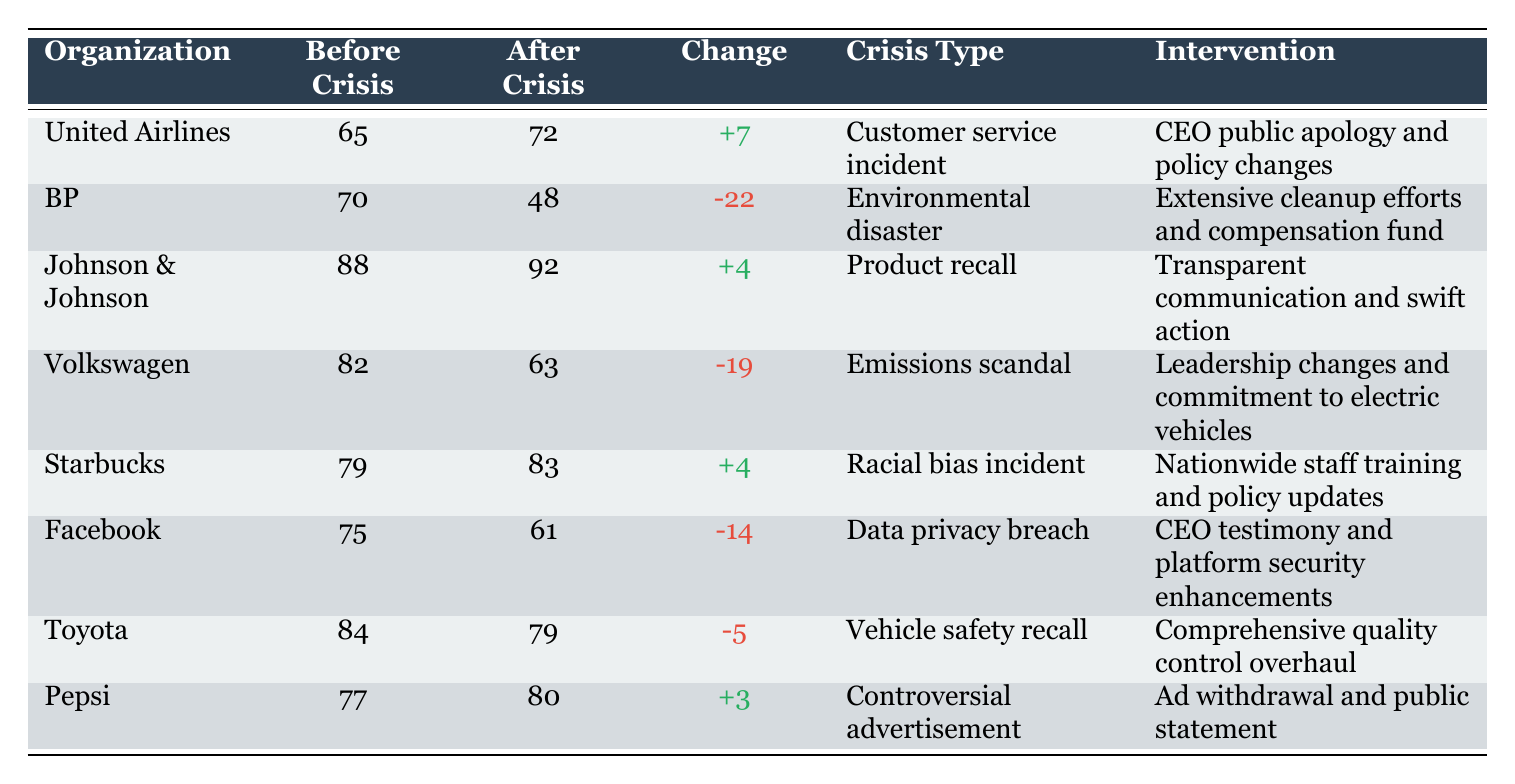What was the public perception rating of United Airlines before the crisis? The table indicates that United Airlines had a public perception rating of 65 before the crisis occurred.
Answer: 65 What intervention did Johnson & Johnson implement after their crisis? According to the table, Johnson & Johnson implemented "Transparent communication and swift action" after their crisis intervention.
Answer: Transparent communication and swift action Which organization experienced the largest decrease in public perception ratings after a crisis? By examining the table, BP's rating decreased from 70 to 48, which is a change of -22, the largest among all organizations.
Answer: BP What is the average public perception rating before the crises for the organizations listed? To calculate the average, sum the ratings before the crises: (65 + 70 + 88 + 82 + 79 + 75 + 84 + 77) = 720. There are 8 organizations, so the average is 720/8 = 90.
Answer: 90 Did Starbucks improve its public perception rating after addressing its crisis? The table shows that Starbucks' rating increased from 79 to 83, indicating an improvement in public perception after their crisis intervention.
Answer: Yes Which type of crisis caused the highest negative change in public perception rating? By evaluating the changes in ratings, BP suffered a change of -22 after the environmental disaster, which is the highest negative change present in the table.
Answer: Environmental disaster After which crisis did Volkswagen experience a fall in public perception rating? The table states that Volkswagen's public perception rating dropped from 82 to 63 due to the emissions scandal.
Answer: Emissions scandal What was the change in public perception for Toyota? The table indicates that Toyota's public perception rating changed from 84 to 79, resulting in a decrease of -5.
Answer: -5 Was there any organization that showed no negative change after a crisis? The table suggests that not all organizations experienced a negative change; for instance, Starbucks' rating increased from 79 to 83, showing no negative change.
Answer: Yes 